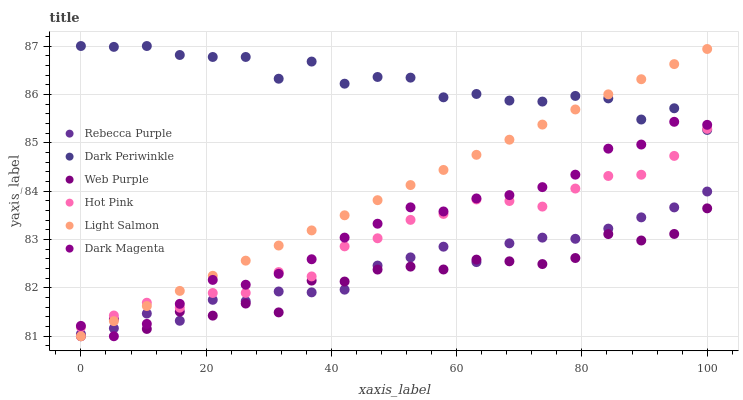Does Web Purple have the minimum area under the curve?
Answer yes or no. Yes. Does Dark Periwinkle have the maximum area under the curve?
Answer yes or no. Yes. Does Dark Magenta have the minimum area under the curve?
Answer yes or no. No. Does Dark Magenta have the maximum area under the curve?
Answer yes or no. No. Is Light Salmon the smoothest?
Answer yes or no. Yes. Is Web Purple the roughest?
Answer yes or no. Yes. Is Dark Magenta the smoothest?
Answer yes or no. No. Is Dark Magenta the roughest?
Answer yes or no. No. Does Light Salmon have the lowest value?
Answer yes or no. Yes. Does Hot Pink have the lowest value?
Answer yes or no. No. Does Dark Periwinkle have the highest value?
Answer yes or no. Yes. Does Dark Magenta have the highest value?
Answer yes or no. No. Is Rebecca Purple less than Hot Pink?
Answer yes or no. Yes. Is Hot Pink greater than Rebecca Purple?
Answer yes or no. Yes. Does Web Purple intersect Rebecca Purple?
Answer yes or no. Yes. Is Web Purple less than Rebecca Purple?
Answer yes or no. No. Is Web Purple greater than Rebecca Purple?
Answer yes or no. No. Does Rebecca Purple intersect Hot Pink?
Answer yes or no. No. 